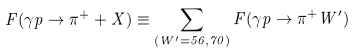<formula> <loc_0><loc_0><loc_500><loc_500>F ( \gamma p \to \pi ^ { + } + X ) \equiv \sum _ { ( W ^ { \prime } = { 5 6 , 7 0 } ) } F ( \gamma p \to \pi ^ { + } W ^ { \prime } )</formula> 